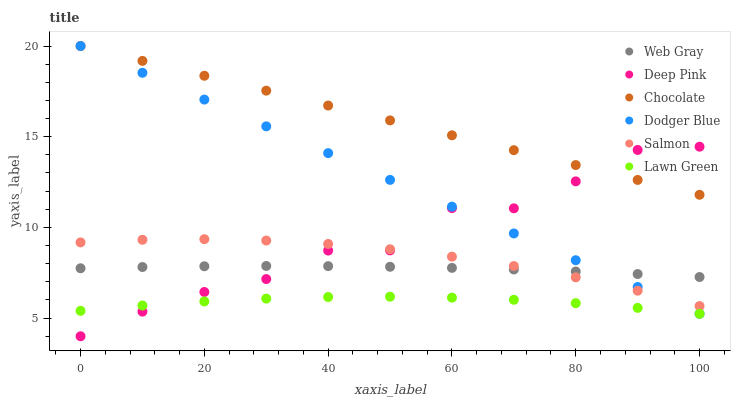Does Lawn Green have the minimum area under the curve?
Answer yes or no. Yes. Does Chocolate have the maximum area under the curve?
Answer yes or no. Yes. Does Web Gray have the minimum area under the curve?
Answer yes or no. No. Does Web Gray have the maximum area under the curve?
Answer yes or no. No. Is Dodger Blue the smoothest?
Answer yes or no. Yes. Is Deep Pink the roughest?
Answer yes or no. Yes. Is Web Gray the smoothest?
Answer yes or no. No. Is Web Gray the roughest?
Answer yes or no. No. Does Deep Pink have the lowest value?
Answer yes or no. Yes. Does Web Gray have the lowest value?
Answer yes or no. No. Does Dodger Blue have the highest value?
Answer yes or no. Yes. Does Web Gray have the highest value?
Answer yes or no. No. Is Web Gray less than Chocolate?
Answer yes or no. Yes. Is Salmon greater than Lawn Green?
Answer yes or no. Yes. Does Deep Pink intersect Dodger Blue?
Answer yes or no. Yes. Is Deep Pink less than Dodger Blue?
Answer yes or no. No. Is Deep Pink greater than Dodger Blue?
Answer yes or no. No. Does Web Gray intersect Chocolate?
Answer yes or no. No. 